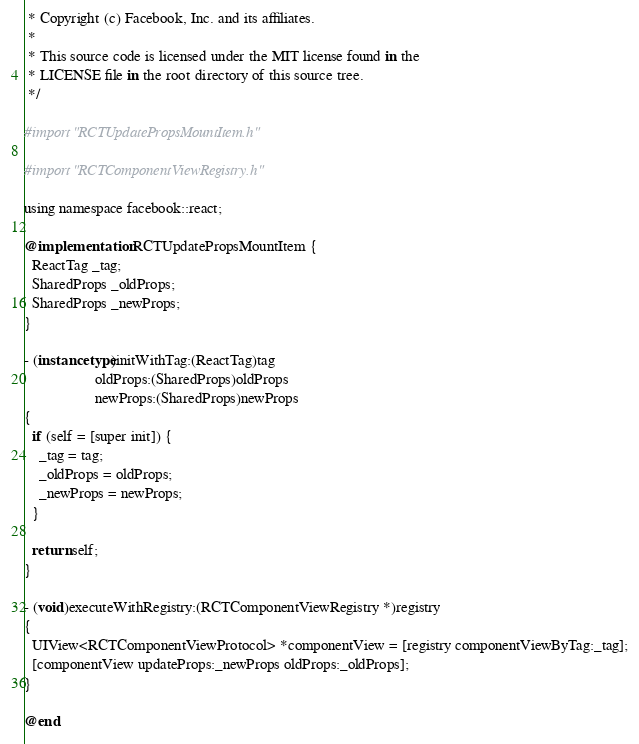Convert code to text. <code><loc_0><loc_0><loc_500><loc_500><_ObjectiveC_> * Copyright (c) Facebook, Inc. and its affiliates.
 *
 * This source code is licensed under the MIT license found in the
 * LICENSE file in the root directory of this source tree.
 */

#import "RCTUpdatePropsMountItem.h"

#import "RCTComponentViewRegistry.h"

using namespace facebook::react;

@implementation RCTUpdatePropsMountItem {
  ReactTag _tag;
  SharedProps _oldProps;
  SharedProps _newProps;
}

- (instancetype)initWithTag:(ReactTag)tag
                   oldProps:(SharedProps)oldProps
                   newProps:(SharedProps)newProps
{
  if (self = [super init]) {
    _tag = tag;
    _oldProps = oldProps;
    _newProps = newProps;
  }

  return self;
}

- (void)executeWithRegistry:(RCTComponentViewRegistry *)registry
{
  UIView<RCTComponentViewProtocol> *componentView = [registry componentViewByTag:_tag];
  [componentView updateProps:_newProps oldProps:_oldProps];
}

@end
</code> 